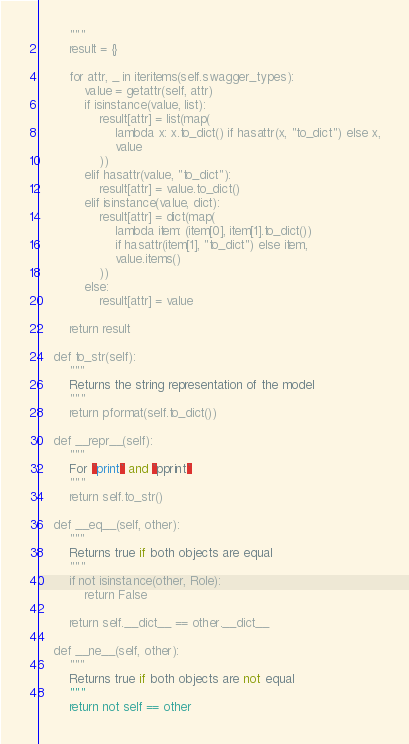<code> <loc_0><loc_0><loc_500><loc_500><_Python_>        """
        result = {}

        for attr, _ in iteritems(self.swagger_types):
            value = getattr(self, attr)
            if isinstance(value, list):
                result[attr] = list(map(
                    lambda x: x.to_dict() if hasattr(x, "to_dict") else x,
                    value
                ))
            elif hasattr(value, "to_dict"):
                result[attr] = value.to_dict()
            elif isinstance(value, dict):
                result[attr] = dict(map(
                    lambda item: (item[0], item[1].to_dict())
                    if hasattr(item[1], "to_dict") else item,
                    value.items()
                ))
            else:
                result[attr] = value

        return result

    def to_str(self):
        """
        Returns the string representation of the model
        """
        return pformat(self.to_dict())

    def __repr__(self):
        """
        For `print` and `pprint`
        """
        return self.to_str()

    def __eq__(self, other):
        """
        Returns true if both objects are equal
        """
        if not isinstance(other, Role):
            return False

        return self.__dict__ == other.__dict__

    def __ne__(self, other):
        """
        Returns true if both objects are not equal
        """
        return not self == other
</code> 